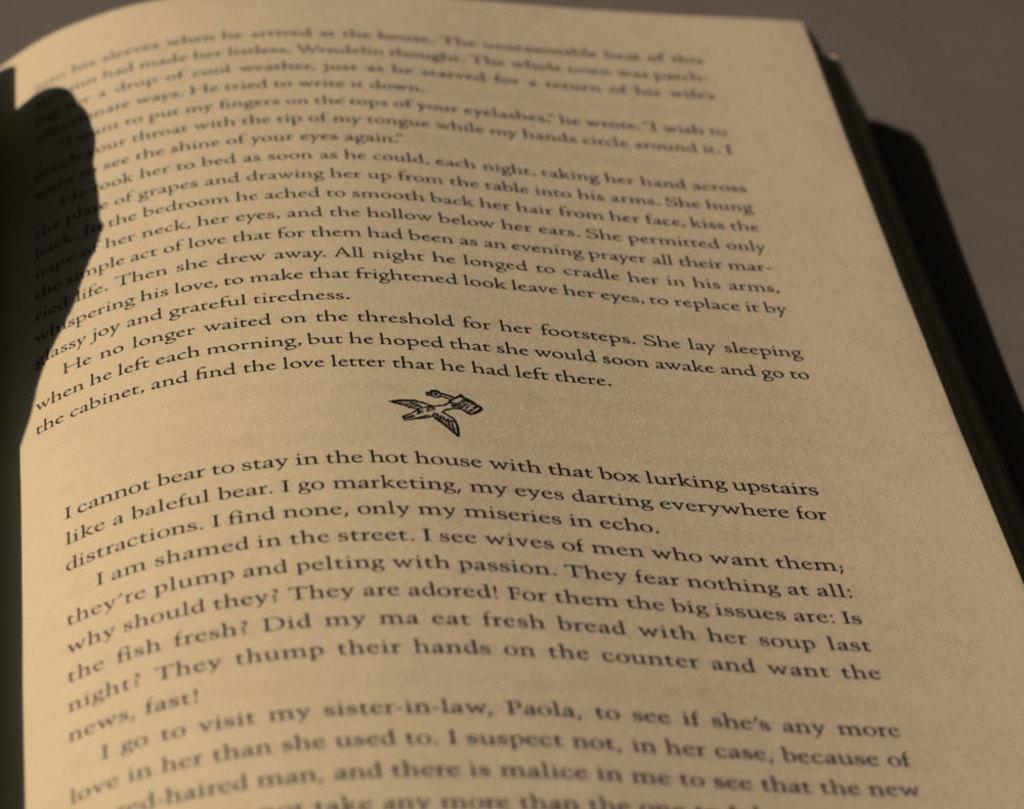<image>
Share a concise interpretation of the image provided. A book page is laying open on a page that has the words, "I cannot bear to stay in the hot house...", written in the second paragraph. 